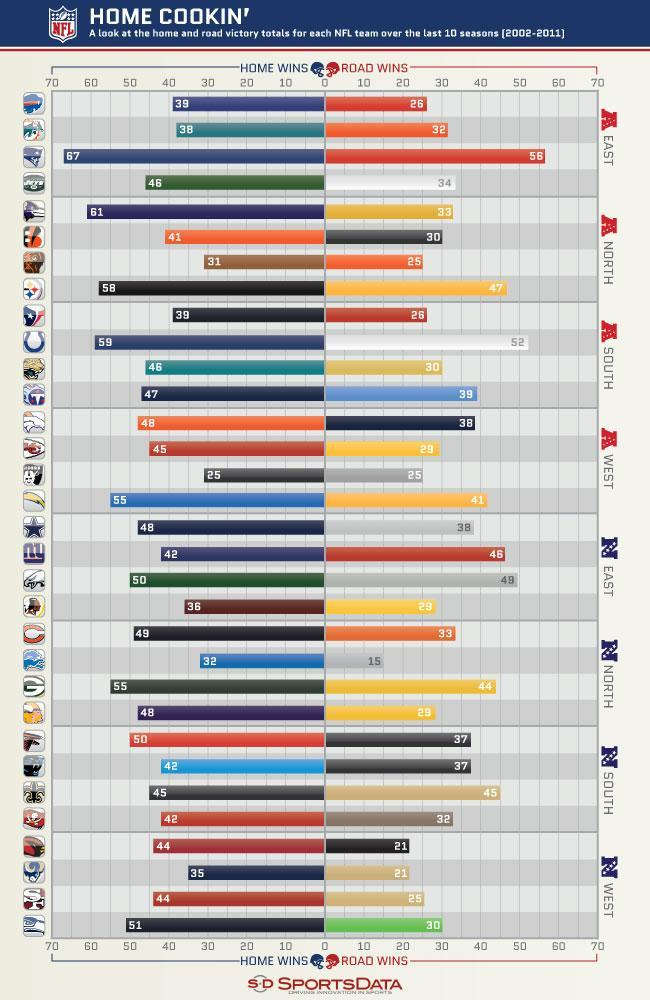Which team scores the highest number of home win among north, south, east, and west of American football conference?
Answer the question with a short phrase. New England Patriots Which team has won 44 road wins and 55 home wins in NFC ? Green Bay Packers What is the least number of road wins by the NFC West? 21 What is the highest score of  road wins among north, south, east and west of the National Football conference ? 49 